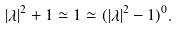Convert formula to latex. <formula><loc_0><loc_0><loc_500><loc_500>| \lambda | ^ { 2 } + 1 \simeq 1 \simeq ( | \lambda | ^ { 2 } - 1 ) ^ { 0 } .</formula> 